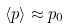Convert formula to latex. <formula><loc_0><loc_0><loc_500><loc_500>\langle p \rangle \approx p _ { 0 }</formula> 